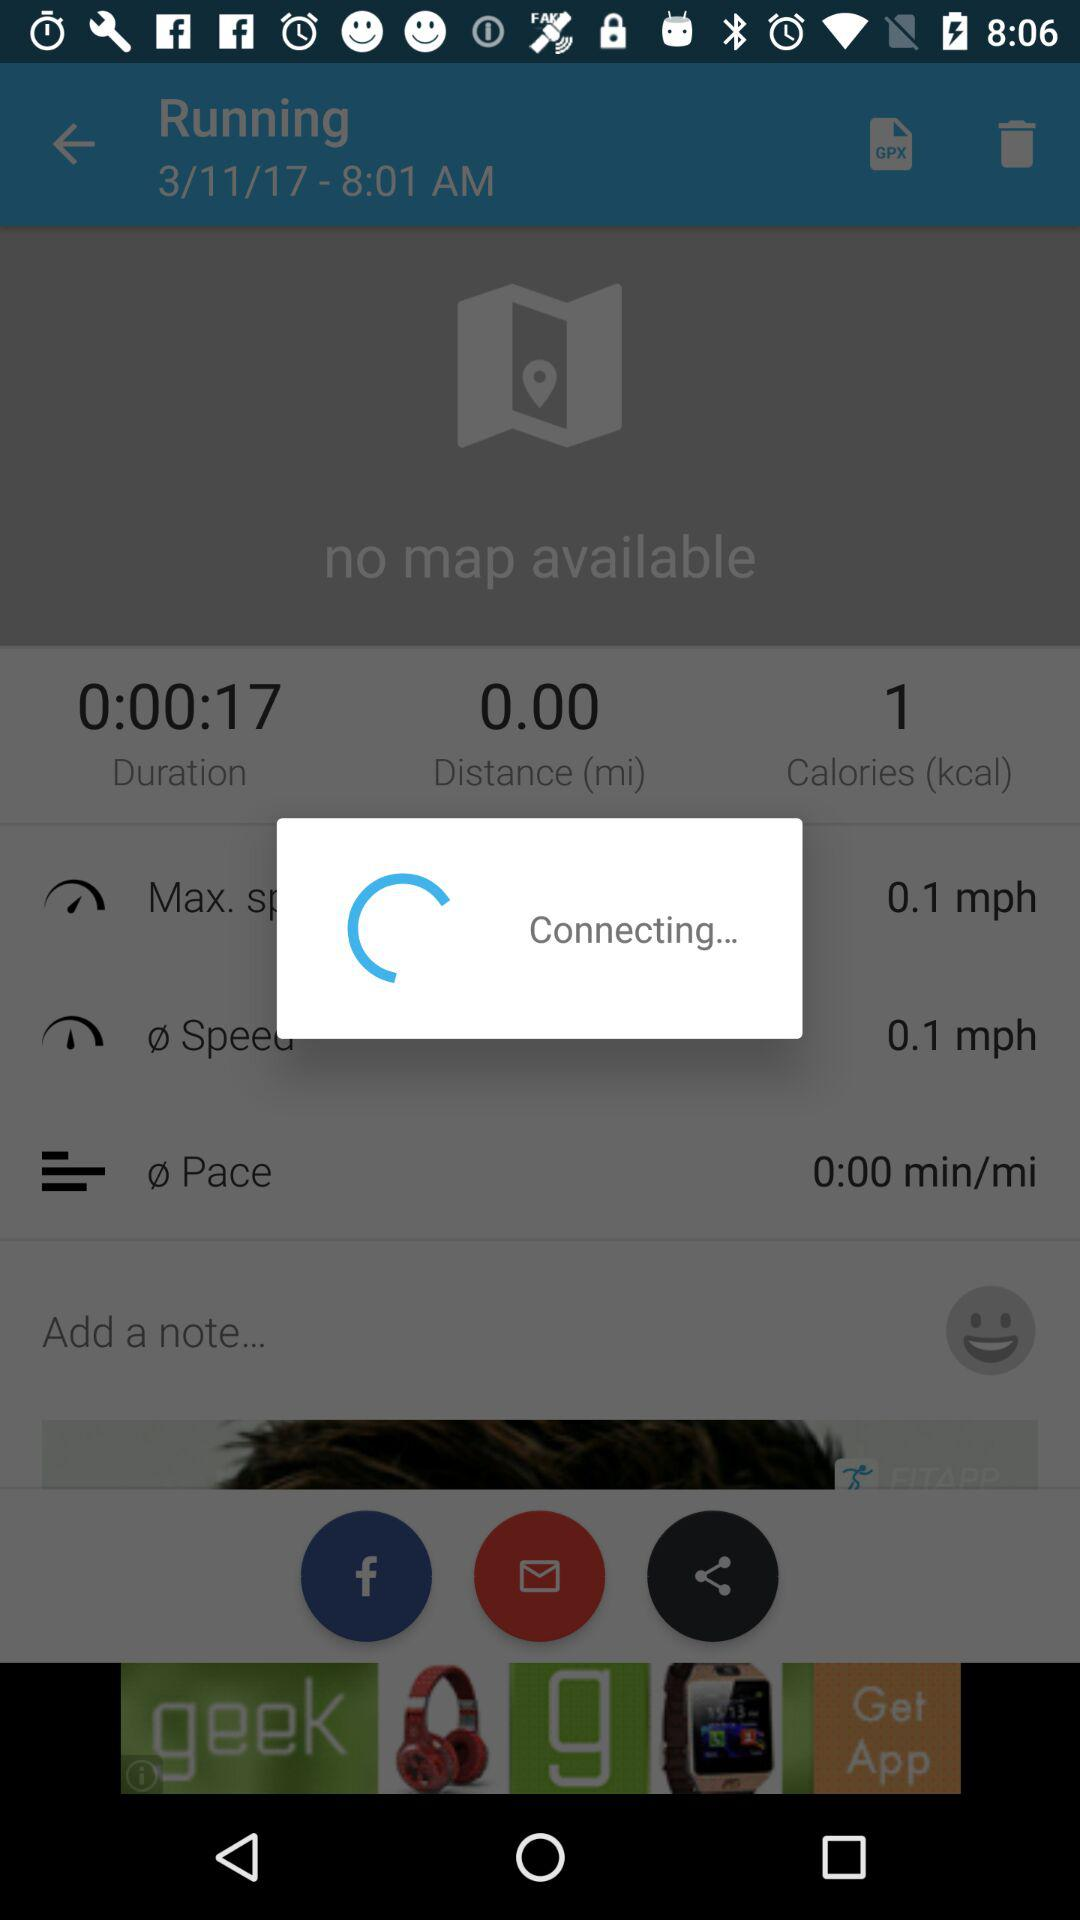Is there any map available? There is no map available. 